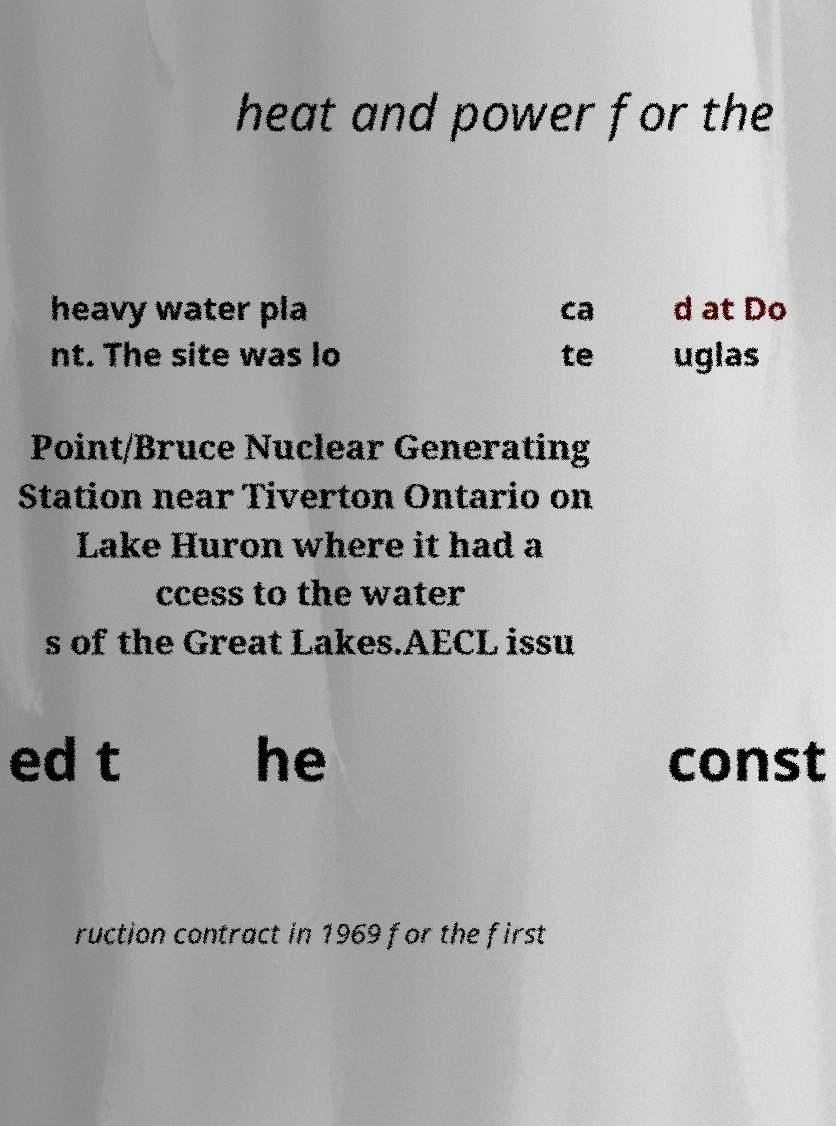Please read and relay the text visible in this image. What does it say? heat and power for the heavy water pla nt. The site was lo ca te d at Do uglas Point/Bruce Nuclear Generating Station near Tiverton Ontario on Lake Huron where it had a ccess to the water s of the Great Lakes.AECL issu ed t he const ruction contract in 1969 for the first 